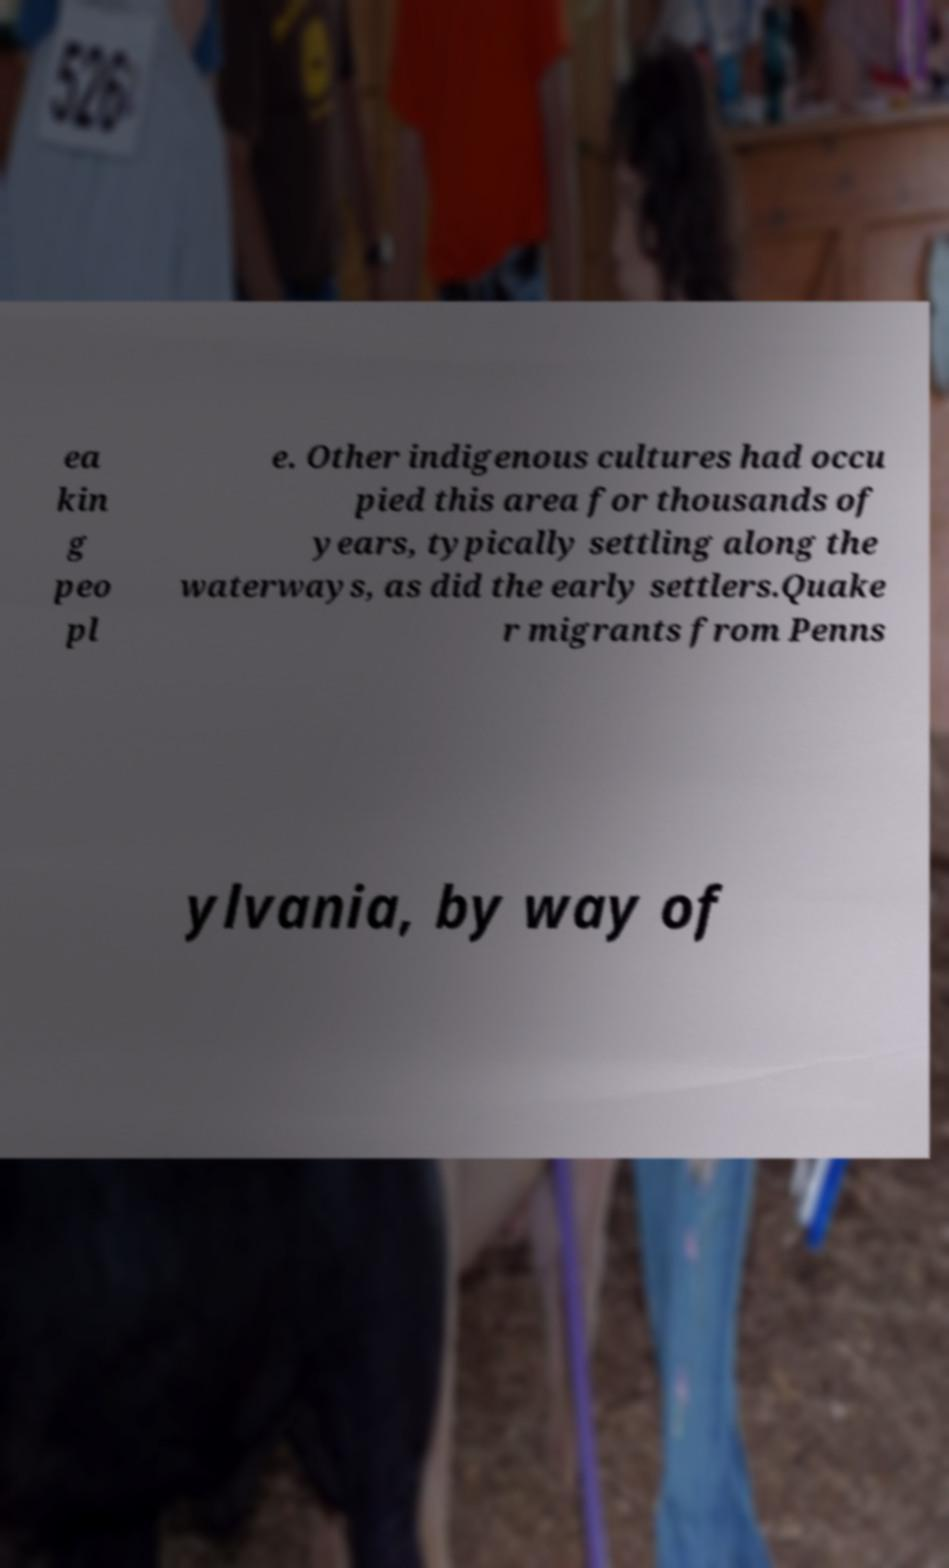Could you extract and type out the text from this image? ea kin g peo pl e. Other indigenous cultures had occu pied this area for thousands of years, typically settling along the waterways, as did the early settlers.Quake r migrants from Penns ylvania, by way of 